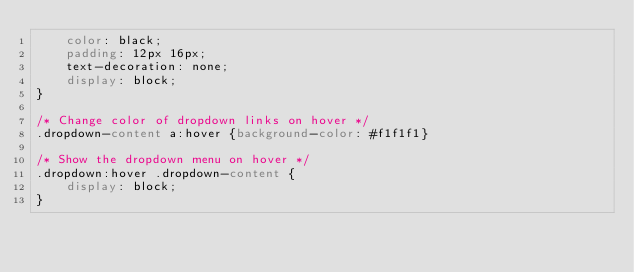Convert code to text. <code><loc_0><loc_0><loc_500><loc_500><_CSS_>    color: black;
    padding: 12px 16px;
    text-decoration: none;
    display: block;
}

/* Change color of dropdown links on hover */
.dropdown-content a:hover {background-color: #f1f1f1}

/* Show the dropdown menu on hover */
.dropdown:hover .dropdown-content {
    display: block;
}



</code> 